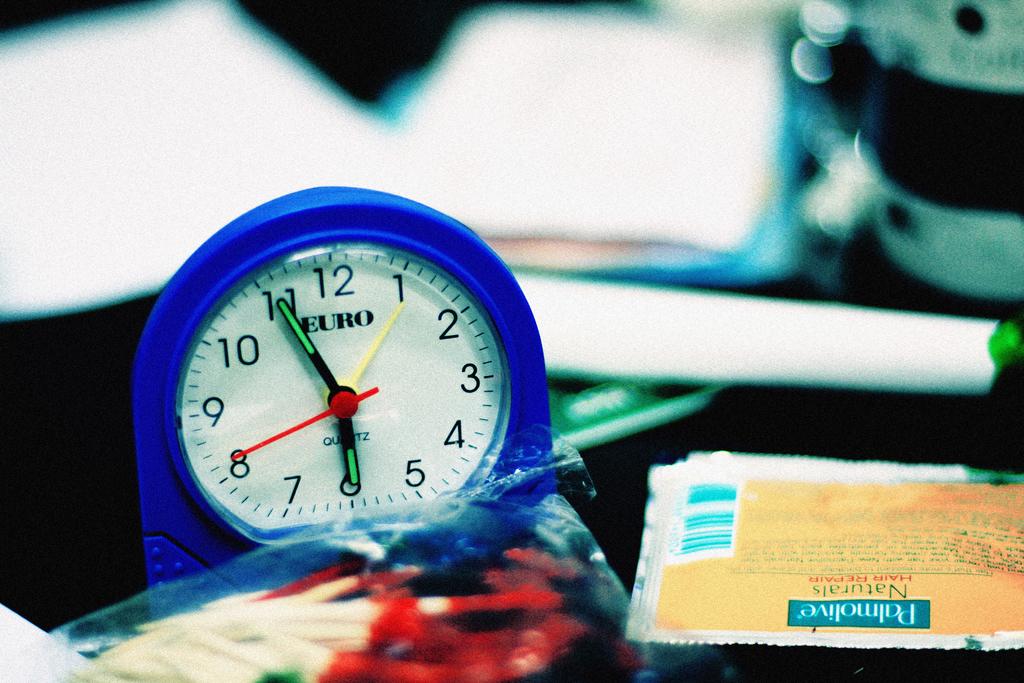What company logo is printed on the clock face?
Ensure brevity in your answer.  Euro. 